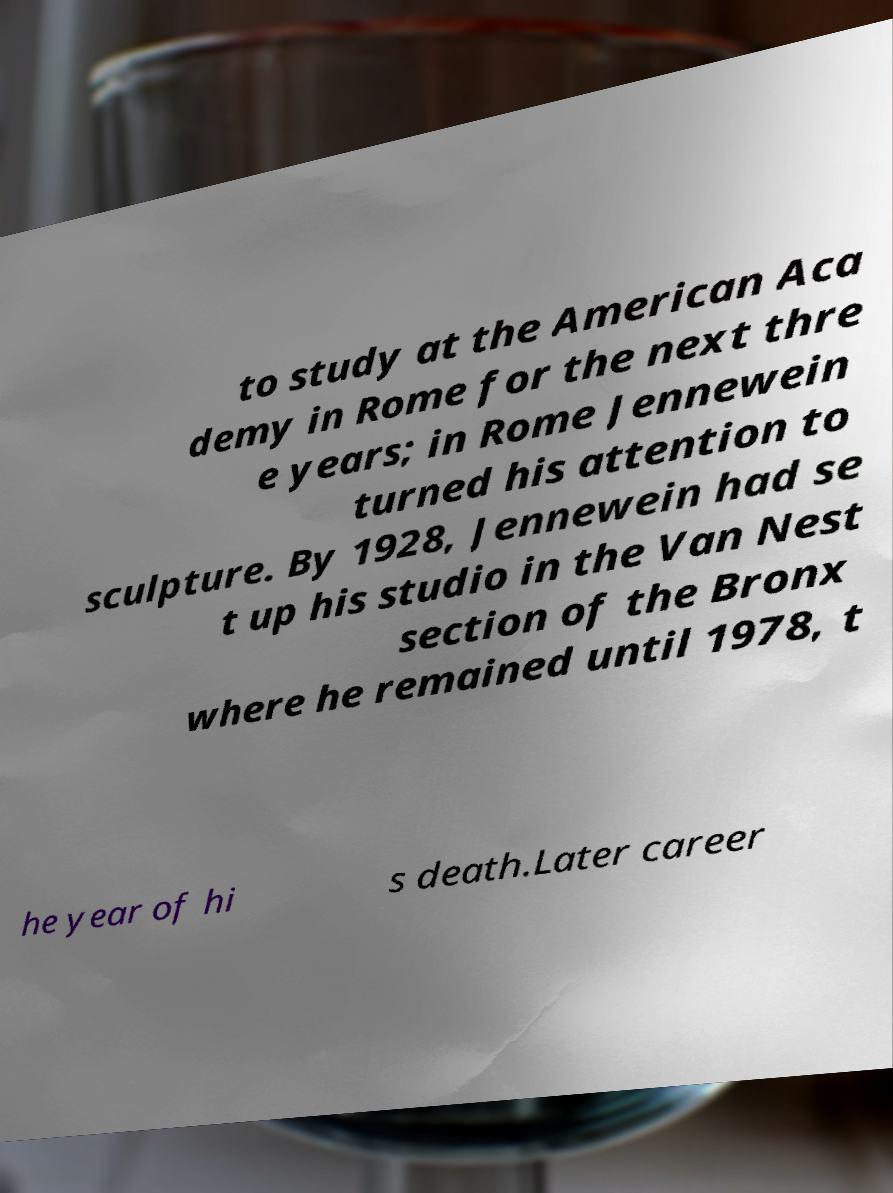There's text embedded in this image that I need extracted. Can you transcribe it verbatim? to study at the American Aca demy in Rome for the next thre e years; in Rome Jennewein turned his attention to sculpture. By 1928, Jennewein had se t up his studio in the Van Nest section of the Bronx where he remained until 1978, t he year of hi s death.Later career 